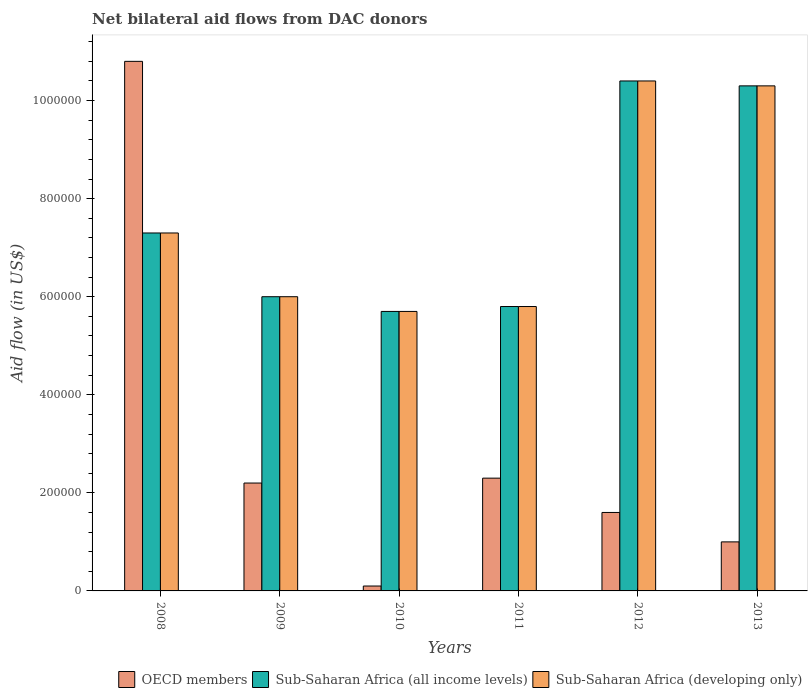How many different coloured bars are there?
Provide a succinct answer. 3. How many groups of bars are there?
Your response must be concise. 6. Are the number of bars per tick equal to the number of legend labels?
Your answer should be very brief. Yes. Are the number of bars on each tick of the X-axis equal?
Your answer should be compact. Yes. How many bars are there on the 5th tick from the left?
Your answer should be very brief. 3. In how many cases, is the number of bars for a given year not equal to the number of legend labels?
Your answer should be compact. 0. What is the net bilateral aid flow in Sub-Saharan Africa (all income levels) in 2008?
Give a very brief answer. 7.30e+05. Across all years, what is the maximum net bilateral aid flow in Sub-Saharan Africa (all income levels)?
Provide a succinct answer. 1.04e+06. Across all years, what is the minimum net bilateral aid flow in OECD members?
Your answer should be very brief. 10000. In which year was the net bilateral aid flow in Sub-Saharan Africa (developing only) minimum?
Keep it short and to the point. 2010. What is the total net bilateral aid flow in Sub-Saharan Africa (all income levels) in the graph?
Your answer should be very brief. 4.55e+06. What is the difference between the net bilateral aid flow in Sub-Saharan Africa (all income levels) in 2012 and that in 2013?
Your answer should be compact. 10000. What is the difference between the net bilateral aid flow in OECD members in 2009 and the net bilateral aid flow in Sub-Saharan Africa (developing only) in 2013?
Your answer should be compact. -8.10e+05. What is the average net bilateral aid flow in Sub-Saharan Africa (all income levels) per year?
Make the answer very short. 7.58e+05. In the year 2012, what is the difference between the net bilateral aid flow in OECD members and net bilateral aid flow in Sub-Saharan Africa (developing only)?
Give a very brief answer. -8.80e+05. In how many years, is the net bilateral aid flow in OECD members greater than 400000 US$?
Offer a terse response. 1. What is the ratio of the net bilateral aid flow in OECD members in 2009 to that in 2012?
Your response must be concise. 1.38. Is the net bilateral aid flow in OECD members in 2009 less than that in 2010?
Your answer should be compact. No. What is the difference between the highest and the second highest net bilateral aid flow in OECD members?
Your answer should be compact. 8.50e+05. What is the difference between the highest and the lowest net bilateral aid flow in OECD members?
Offer a very short reply. 1.07e+06. In how many years, is the net bilateral aid flow in Sub-Saharan Africa (all income levels) greater than the average net bilateral aid flow in Sub-Saharan Africa (all income levels) taken over all years?
Your answer should be compact. 2. What does the 2nd bar from the left in 2009 represents?
Make the answer very short. Sub-Saharan Africa (all income levels). What does the 1st bar from the right in 2010 represents?
Offer a terse response. Sub-Saharan Africa (developing only). How many bars are there?
Your answer should be very brief. 18. Are all the bars in the graph horizontal?
Keep it short and to the point. No. How many years are there in the graph?
Ensure brevity in your answer.  6. What is the difference between two consecutive major ticks on the Y-axis?
Offer a very short reply. 2.00e+05. Are the values on the major ticks of Y-axis written in scientific E-notation?
Ensure brevity in your answer.  No. Does the graph contain any zero values?
Your answer should be compact. No. Where does the legend appear in the graph?
Your answer should be very brief. Bottom right. How many legend labels are there?
Provide a short and direct response. 3. What is the title of the graph?
Your response must be concise. Net bilateral aid flows from DAC donors. Does "Belarus" appear as one of the legend labels in the graph?
Keep it short and to the point. No. What is the label or title of the Y-axis?
Your answer should be compact. Aid flow (in US$). What is the Aid flow (in US$) of OECD members in 2008?
Offer a terse response. 1.08e+06. What is the Aid flow (in US$) in Sub-Saharan Africa (all income levels) in 2008?
Offer a terse response. 7.30e+05. What is the Aid flow (in US$) in Sub-Saharan Africa (developing only) in 2008?
Your answer should be compact. 7.30e+05. What is the Aid flow (in US$) of Sub-Saharan Africa (all income levels) in 2009?
Offer a terse response. 6.00e+05. What is the Aid flow (in US$) in Sub-Saharan Africa (developing only) in 2009?
Offer a terse response. 6.00e+05. What is the Aid flow (in US$) of OECD members in 2010?
Your answer should be very brief. 10000. What is the Aid flow (in US$) of Sub-Saharan Africa (all income levels) in 2010?
Provide a succinct answer. 5.70e+05. What is the Aid flow (in US$) of Sub-Saharan Africa (developing only) in 2010?
Keep it short and to the point. 5.70e+05. What is the Aid flow (in US$) of OECD members in 2011?
Make the answer very short. 2.30e+05. What is the Aid flow (in US$) in Sub-Saharan Africa (all income levels) in 2011?
Give a very brief answer. 5.80e+05. What is the Aid flow (in US$) of Sub-Saharan Africa (developing only) in 2011?
Your answer should be compact. 5.80e+05. What is the Aid flow (in US$) in OECD members in 2012?
Your answer should be very brief. 1.60e+05. What is the Aid flow (in US$) in Sub-Saharan Africa (all income levels) in 2012?
Provide a short and direct response. 1.04e+06. What is the Aid flow (in US$) of Sub-Saharan Africa (developing only) in 2012?
Offer a terse response. 1.04e+06. What is the Aid flow (in US$) in Sub-Saharan Africa (all income levels) in 2013?
Your answer should be compact. 1.03e+06. What is the Aid flow (in US$) of Sub-Saharan Africa (developing only) in 2013?
Give a very brief answer. 1.03e+06. Across all years, what is the maximum Aid flow (in US$) in OECD members?
Provide a short and direct response. 1.08e+06. Across all years, what is the maximum Aid flow (in US$) of Sub-Saharan Africa (all income levels)?
Give a very brief answer. 1.04e+06. Across all years, what is the maximum Aid flow (in US$) of Sub-Saharan Africa (developing only)?
Provide a short and direct response. 1.04e+06. Across all years, what is the minimum Aid flow (in US$) in OECD members?
Keep it short and to the point. 10000. Across all years, what is the minimum Aid flow (in US$) in Sub-Saharan Africa (all income levels)?
Offer a very short reply. 5.70e+05. Across all years, what is the minimum Aid flow (in US$) in Sub-Saharan Africa (developing only)?
Provide a short and direct response. 5.70e+05. What is the total Aid flow (in US$) in OECD members in the graph?
Keep it short and to the point. 1.80e+06. What is the total Aid flow (in US$) in Sub-Saharan Africa (all income levels) in the graph?
Your answer should be compact. 4.55e+06. What is the total Aid flow (in US$) in Sub-Saharan Africa (developing only) in the graph?
Ensure brevity in your answer.  4.55e+06. What is the difference between the Aid flow (in US$) in OECD members in 2008 and that in 2009?
Your answer should be very brief. 8.60e+05. What is the difference between the Aid flow (in US$) of Sub-Saharan Africa (all income levels) in 2008 and that in 2009?
Ensure brevity in your answer.  1.30e+05. What is the difference between the Aid flow (in US$) of OECD members in 2008 and that in 2010?
Offer a very short reply. 1.07e+06. What is the difference between the Aid flow (in US$) in Sub-Saharan Africa (all income levels) in 2008 and that in 2010?
Ensure brevity in your answer.  1.60e+05. What is the difference between the Aid flow (in US$) in Sub-Saharan Africa (developing only) in 2008 and that in 2010?
Offer a very short reply. 1.60e+05. What is the difference between the Aid flow (in US$) of OECD members in 2008 and that in 2011?
Your answer should be very brief. 8.50e+05. What is the difference between the Aid flow (in US$) of Sub-Saharan Africa (all income levels) in 2008 and that in 2011?
Your response must be concise. 1.50e+05. What is the difference between the Aid flow (in US$) in Sub-Saharan Africa (developing only) in 2008 and that in 2011?
Offer a terse response. 1.50e+05. What is the difference between the Aid flow (in US$) of OECD members in 2008 and that in 2012?
Keep it short and to the point. 9.20e+05. What is the difference between the Aid flow (in US$) in Sub-Saharan Africa (all income levels) in 2008 and that in 2012?
Make the answer very short. -3.10e+05. What is the difference between the Aid flow (in US$) of Sub-Saharan Africa (developing only) in 2008 and that in 2012?
Provide a short and direct response. -3.10e+05. What is the difference between the Aid flow (in US$) in OECD members in 2008 and that in 2013?
Offer a terse response. 9.80e+05. What is the difference between the Aid flow (in US$) of OECD members in 2009 and that in 2010?
Your response must be concise. 2.10e+05. What is the difference between the Aid flow (in US$) of OECD members in 2009 and that in 2011?
Your answer should be compact. -10000. What is the difference between the Aid flow (in US$) of Sub-Saharan Africa (developing only) in 2009 and that in 2011?
Give a very brief answer. 2.00e+04. What is the difference between the Aid flow (in US$) in Sub-Saharan Africa (all income levels) in 2009 and that in 2012?
Offer a very short reply. -4.40e+05. What is the difference between the Aid flow (in US$) of Sub-Saharan Africa (developing only) in 2009 and that in 2012?
Your answer should be compact. -4.40e+05. What is the difference between the Aid flow (in US$) in OECD members in 2009 and that in 2013?
Give a very brief answer. 1.20e+05. What is the difference between the Aid flow (in US$) of Sub-Saharan Africa (all income levels) in 2009 and that in 2013?
Give a very brief answer. -4.30e+05. What is the difference between the Aid flow (in US$) of Sub-Saharan Africa (developing only) in 2009 and that in 2013?
Your answer should be very brief. -4.30e+05. What is the difference between the Aid flow (in US$) in OECD members in 2010 and that in 2011?
Provide a succinct answer. -2.20e+05. What is the difference between the Aid flow (in US$) in Sub-Saharan Africa (all income levels) in 2010 and that in 2012?
Your response must be concise. -4.70e+05. What is the difference between the Aid flow (in US$) of Sub-Saharan Africa (developing only) in 2010 and that in 2012?
Offer a terse response. -4.70e+05. What is the difference between the Aid flow (in US$) in Sub-Saharan Africa (all income levels) in 2010 and that in 2013?
Ensure brevity in your answer.  -4.60e+05. What is the difference between the Aid flow (in US$) in Sub-Saharan Africa (developing only) in 2010 and that in 2013?
Keep it short and to the point. -4.60e+05. What is the difference between the Aid flow (in US$) in Sub-Saharan Africa (all income levels) in 2011 and that in 2012?
Provide a short and direct response. -4.60e+05. What is the difference between the Aid flow (in US$) in Sub-Saharan Africa (developing only) in 2011 and that in 2012?
Offer a terse response. -4.60e+05. What is the difference between the Aid flow (in US$) of Sub-Saharan Africa (all income levels) in 2011 and that in 2013?
Make the answer very short. -4.50e+05. What is the difference between the Aid flow (in US$) of Sub-Saharan Africa (developing only) in 2011 and that in 2013?
Offer a terse response. -4.50e+05. What is the difference between the Aid flow (in US$) in Sub-Saharan Africa (all income levels) in 2012 and that in 2013?
Make the answer very short. 10000. What is the difference between the Aid flow (in US$) of Sub-Saharan Africa (developing only) in 2012 and that in 2013?
Ensure brevity in your answer.  10000. What is the difference between the Aid flow (in US$) in OECD members in 2008 and the Aid flow (in US$) in Sub-Saharan Africa (all income levels) in 2009?
Offer a very short reply. 4.80e+05. What is the difference between the Aid flow (in US$) of Sub-Saharan Africa (all income levels) in 2008 and the Aid flow (in US$) of Sub-Saharan Africa (developing only) in 2009?
Keep it short and to the point. 1.30e+05. What is the difference between the Aid flow (in US$) of OECD members in 2008 and the Aid flow (in US$) of Sub-Saharan Africa (all income levels) in 2010?
Your answer should be compact. 5.10e+05. What is the difference between the Aid flow (in US$) in OECD members in 2008 and the Aid flow (in US$) in Sub-Saharan Africa (developing only) in 2010?
Offer a very short reply. 5.10e+05. What is the difference between the Aid flow (in US$) of Sub-Saharan Africa (all income levels) in 2008 and the Aid flow (in US$) of Sub-Saharan Africa (developing only) in 2010?
Give a very brief answer. 1.60e+05. What is the difference between the Aid flow (in US$) in OECD members in 2008 and the Aid flow (in US$) in Sub-Saharan Africa (developing only) in 2011?
Keep it short and to the point. 5.00e+05. What is the difference between the Aid flow (in US$) of Sub-Saharan Africa (all income levels) in 2008 and the Aid flow (in US$) of Sub-Saharan Africa (developing only) in 2011?
Provide a succinct answer. 1.50e+05. What is the difference between the Aid flow (in US$) of OECD members in 2008 and the Aid flow (in US$) of Sub-Saharan Africa (developing only) in 2012?
Offer a very short reply. 4.00e+04. What is the difference between the Aid flow (in US$) in Sub-Saharan Africa (all income levels) in 2008 and the Aid flow (in US$) in Sub-Saharan Africa (developing only) in 2012?
Your answer should be compact. -3.10e+05. What is the difference between the Aid flow (in US$) of Sub-Saharan Africa (all income levels) in 2008 and the Aid flow (in US$) of Sub-Saharan Africa (developing only) in 2013?
Ensure brevity in your answer.  -3.00e+05. What is the difference between the Aid flow (in US$) of OECD members in 2009 and the Aid flow (in US$) of Sub-Saharan Africa (all income levels) in 2010?
Make the answer very short. -3.50e+05. What is the difference between the Aid flow (in US$) of OECD members in 2009 and the Aid flow (in US$) of Sub-Saharan Africa (developing only) in 2010?
Your response must be concise. -3.50e+05. What is the difference between the Aid flow (in US$) of OECD members in 2009 and the Aid flow (in US$) of Sub-Saharan Africa (all income levels) in 2011?
Your answer should be compact. -3.60e+05. What is the difference between the Aid flow (in US$) in OECD members in 2009 and the Aid flow (in US$) in Sub-Saharan Africa (developing only) in 2011?
Offer a terse response. -3.60e+05. What is the difference between the Aid flow (in US$) in Sub-Saharan Africa (all income levels) in 2009 and the Aid flow (in US$) in Sub-Saharan Africa (developing only) in 2011?
Ensure brevity in your answer.  2.00e+04. What is the difference between the Aid flow (in US$) of OECD members in 2009 and the Aid flow (in US$) of Sub-Saharan Africa (all income levels) in 2012?
Your response must be concise. -8.20e+05. What is the difference between the Aid flow (in US$) in OECD members in 2009 and the Aid flow (in US$) in Sub-Saharan Africa (developing only) in 2012?
Provide a succinct answer. -8.20e+05. What is the difference between the Aid flow (in US$) in Sub-Saharan Africa (all income levels) in 2009 and the Aid flow (in US$) in Sub-Saharan Africa (developing only) in 2012?
Offer a terse response. -4.40e+05. What is the difference between the Aid flow (in US$) of OECD members in 2009 and the Aid flow (in US$) of Sub-Saharan Africa (all income levels) in 2013?
Provide a short and direct response. -8.10e+05. What is the difference between the Aid flow (in US$) of OECD members in 2009 and the Aid flow (in US$) of Sub-Saharan Africa (developing only) in 2013?
Your response must be concise. -8.10e+05. What is the difference between the Aid flow (in US$) in Sub-Saharan Africa (all income levels) in 2009 and the Aid flow (in US$) in Sub-Saharan Africa (developing only) in 2013?
Ensure brevity in your answer.  -4.30e+05. What is the difference between the Aid flow (in US$) in OECD members in 2010 and the Aid flow (in US$) in Sub-Saharan Africa (all income levels) in 2011?
Give a very brief answer. -5.70e+05. What is the difference between the Aid flow (in US$) in OECD members in 2010 and the Aid flow (in US$) in Sub-Saharan Africa (developing only) in 2011?
Offer a very short reply. -5.70e+05. What is the difference between the Aid flow (in US$) in Sub-Saharan Africa (all income levels) in 2010 and the Aid flow (in US$) in Sub-Saharan Africa (developing only) in 2011?
Offer a terse response. -10000. What is the difference between the Aid flow (in US$) in OECD members in 2010 and the Aid flow (in US$) in Sub-Saharan Africa (all income levels) in 2012?
Ensure brevity in your answer.  -1.03e+06. What is the difference between the Aid flow (in US$) of OECD members in 2010 and the Aid flow (in US$) of Sub-Saharan Africa (developing only) in 2012?
Offer a terse response. -1.03e+06. What is the difference between the Aid flow (in US$) of Sub-Saharan Africa (all income levels) in 2010 and the Aid flow (in US$) of Sub-Saharan Africa (developing only) in 2012?
Give a very brief answer. -4.70e+05. What is the difference between the Aid flow (in US$) in OECD members in 2010 and the Aid flow (in US$) in Sub-Saharan Africa (all income levels) in 2013?
Your response must be concise. -1.02e+06. What is the difference between the Aid flow (in US$) in OECD members in 2010 and the Aid flow (in US$) in Sub-Saharan Africa (developing only) in 2013?
Give a very brief answer. -1.02e+06. What is the difference between the Aid flow (in US$) of Sub-Saharan Africa (all income levels) in 2010 and the Aid flow (in US$) of Sub-Saharan Africa (developing only) in 2013?
Offer a terse response. -4.60e+05. What is the difference between the Aid flow (in US$) of OECD members in 2011 and the Aid flow (in US$) of Sub-Saharan Africa (all income levels) in 2012?
Give a very brief answer. -8.10e+05. What is the difference between the Aid flow (in US$) in OECD members in 2011 and the Aid flow (in US$) in Sub-Saharan Africa (developing only) in 2012?
Ensure brevity in your answer.  -8.10e+05. What is the difference between the Aid flow (in US$) of Sub-Saharan Africa (all income levels) in 2011 and the Aid flow (in US$) of Sub-Saharan Africa (developing only) in 2012?
Your answer should be compact. -4.60e+05. What is the difference between the Aid flow (in US$) of OECD members in 2011 and the Aid flow (in US$) of Sub-Saharan Africa (all income levels) in 2013?
Offer a terse response. -8.00e+05. What is the difference between the Aid flow (in US$) of OECD members in 2011 and the Aid flow (in US$) of Sub-Saharan Africa (developing only) in 2013?
Ensure brevity in your answer.  -8.00e+05. What is the difference between the Aid flow (in US$) of Sub-Saharan Africa (all income levels) in 2011 and the Aid flow (in US$) of Sub-Saharan Africa (developing only) in 2013?
Your answer should be very brief. -4.50e+05. What is the difference between the Aid flow (in US$) of OECD members in 2012 and the Aid flow (in US$) of Sub-Saharan Africa (all income levels) in 2013?
Your answer should be compact. -8.70e+05. What is the difference between the Aid flow (in US$) in OECD members in 2012 and the Aid flow (in US$) in Sub-Saharan Africa (developing only) in 2013?
Provide a short and direct response. -8.70e+05. What is the average Aid flow (in US$) of Sub-Saharan Africa (all income levels) per year?
Provide a short and direct response. 7.58e+05. What is the average Aid flow (in US$) of Sub-Saharan Africa (developing only) per year?
Provide a succinct answer. 7.58e+05. In the year 2008, what is the difference between the Aid flow (in US$) in OECD members and Aid flow (in US$) in Sub-Saharan Africa (all income levels)?
Your answer should be very brief. 3.50e+05. In the year 2008, what is the difference between the Aid flow (in US$) in OECD members and Aid flow (in US$) in Sub-Saharan Africa (developing only)?
Offer a terse response. 3.50e+05. In the year 2009, what is the difference between the Aid flow (in US$) in OECD members and Aid flow (in US$) in Sub-Saharan Africa (all income levels)?
Keep it short and to the point. -3.80e+05. In the year 2009, what is the difference between the Aid flow (in US$) of OECD members and Aid flow (in US$) of Sub-Saharan Africa (developing only)?
Ensure brevity in your answer.  -3.80e+05. In the year 2010, what is the difference between the Aid flow (in US$) in OECD members and Aid flow (in US$) in Sub-Saharan Africa (all income levels)?
Your answer should be compact. -5.60e+05. In the year 2010, what is the difference between the Aid flow (in US$) in OECD members and Aid flow (in US$) in Sub-Saharan Africa (developing only)?
Give a very brief answer. -5.60e+05. In the year 2011, what is the difference between the Aid flow (in US$) of OECD members and Aid flow (in US$) of Sub-Saharan Africa (all income levels)?
Offer a terse response. -3.50e+05. In the year 2011, what is the difference between the Aid flow (in US$) of OECD members and Aid flow (in US$) of Sub-Saharan Africa (developing only)?
Give a very brief answer. -3.50e+05. In the year 2012, what is the difference between the Aid flow (in US$) of OECD members and Aid flow (in US$) of Sub-Saharan Africa (all income levels)?
Offer a terse response. -8.80e+05. In the year 2012, what is the difference between the Aid flow (in US$) in OECD members and Aid flow (in US$) in Sub-Saharan Africa (developing only)?
Your response must be concise. -8.80e+05. In the year 2012, what is the difference between the Aid flow (in US$) of Sub-Saharan Africa (all income levels) and Aid flow (in US$) of Sub-Saharan Africa (developing only)?
Make the answer very short. 0. In the year 2013, what is the difference between the Aid flow (in US$) in OECD members and Aid flow (in US$) in Sub-Saharan Africa (all income levels)?
Your response must be concise. -9.30e+05. In the year 2013, what is the difference between the Aid flow (in US$) of OECD members and Aid flow (in US$) of Sub-Saharan Africa (developing only)?
Your answer should be compact. -9.30e+05. In the year 2013, what is the difference between the Aid flow (in US$) in Sub-Saharan Africa (all income levels) and Aid flow (in US$) in Sub-Saharan Africa (developing only)?
Make the answer very short. 0. What is the ratio of the Aid flow (in US$) in OECD members in 2008 to that in 2009?
Provide a short and direct response. 4.91. What is the ratio of the Aid flow (in US$) in Sub-Saharan Africa (all income levels) in 2008 to that in 2009?
Ensure brevity in your answer.  1.22. What is the ratio of the Aid flow (in US$) of Sub-Saharan Africa (developing only) in 2008 to that in 2009?
Your answer should be compact. 1.22. What is the ratio of the Aid flow (in US$) of OECD members in 2008 to that in 2010?
Ensure brevity in your answer.  108. What is the ratio of the Aid flow (in US$) of Sub-Saharan Africa (all income levels) in 2008 to that in 2010?
Ensure brevity in your answer.  1.28. What is the ratio of the Aid flow (in US$) in Sub-Saharan Africa (developing only) in 2008 to that in 2010?
Your answer should be very brief. 1.28. What is the ratio of the Aid flow (in US$) of OECD members in 2008 to that in 2011?
Make the answer very short. 4.7. What is the ratio of the Aid flow (in US$) of Sub-Saharan Africa (all income levels) in 2008 to that in 2011?
Your answer should be compact. 1.26. What is the ratio of the Aid flow (in US$) of Sub-Saharan Africa (developing only) in 2008 to that in 2011?
Ensure brevity in your answer.  1.26. What is the ratio of the Aid flow (in US$) in OECD members in 2008 to that in 2012?
Your answer should be compact. 6.75. What is the ratio of the Aid flow (in US$) in Sub-Saharan Africa (all income levels) in 2008 to that in 2012?
Offer a very short reply. 0.7. What is the ratio of the Aid flow (in US$) of Sub-Saharan Africa (developing only) in 2008 to that in 2012?
Give a very brief answer. 0.7. What is the ratio of the Aid flow (in US$) in Sub-Saharan Africa (all income levels) in 2008 to that in 2013?
Your answer should be very brief. 0.71. What is the ratio of the Aid flow (in US$) of Sub-Saharan Africa (developing only) in 2008 to that in 2013?
Offer a very short reply. 0.71. What is the ratio of the Aid flow (in US$) of OECD members in 2009 to that in 2010?
Your response must be concise. 22. What is the ratio of the Aid flow (in US$) of Sub-Saharan Africa (all income levels) in 2009 to that in 2010?
Your response must be concise. 1.05. What is the ratio of the Aid flow (in US$) in Sub-Saharan Africa (developing only) in 2009 to that in 2010?
Your answer should be very brief. 1.05. What is the ratio of the Aid flow (in US$) in OECD members in 2009 to that in 2011?
Offer a very short reply. 0.96. What is the ratio of the Aid flow (in US$) of Sub-Saharan Africa (all income levels) in 2009 to that in 2011?
Provide a succinct answer. 1.03. What is the ratio of the Aid flow (in US$) in Sub-Saharan Africa (developing only) in 2009 to that in 2011?
Provide a succinct answer. 1.03. What is the ratio of the Aid flow (in US$) of OECD members in 2009 to that in 2012?
Give a very brief answer. 1.38. What is the ratio of the Aid flow (in US$) of Sub-Saharan Africa (all income levels) in 2009 to that in 2012?
Provide a succinct answer. 0.58. What is the ratio of the Aid flow (in US$) of Sub-Saharan Africa (developing only) in 2009 to that in 2012?
Your answer should be very brief. 0.58. What is the ratio of the Aid flow (in US$) of Sub-Saharan Africa (all income levels) in 2009 to that in 2013?
Give a very brief answer. 0.58. What is the ratio of the Aid flow (in US$) of Sub-Saharan Africa (developing only) in 2009 to that in 2013?
Offer a very short reply. 0.58. What is the ratio of the Aid flow (in US$) in OECD members in 2010 to that in 2011?
Give a very brief answer. 0.04. What is the ratio of the Aid flow (in US$) of Sub-Saharan Africa (all income levels) in 2010 to that in 2011?
Provide a short and direct response. 0.98. What is the ratio of the Aid flow (in US$) of Sub-Saharan Africa (developing only) in 2010 to that in 2011?
Your response must be concise. 0.98. What is the ratio of the Aid flow (in US$) in OECD members in 2010 to that in 2012?
Offer a terse response. 0.06. What is the ratio of the Aid flow (in US$) in Sub-Saharan Africa (all income levels) in 2010 to that in 2012?
Your answer should be compact. 0.55. What is the ratio of the Aid flow (in US$) of Sub-Saharan Africa (developing only) in 2010 to that in 2012?
Provide a short and direct response. 0.55. What is the ratio of the Aid flow (in US$) of OECD members in 2010 to that in 2013?
Your response must be concise. 0.1. What is the ratio of the Aid flow (in US$) in Sub-Saharan Africa (all income levels) in 2010 to that in 2013?
Keep it short and to the point. 0.55. What is the ratio of the Aid flow (in US$) of Sub-Saharan Africa (developing only) in 2010 to that in 2013?
Your answer should be compact. 0.55. What is the ratio of the Aid flow (in US$) of OECD members in 2011 to that in 2012?
Give a very brief answer. 1.44. What is the ratio of the Aid flow (in US$) in Sub-Saharan Africa (all income levels) in 2011 to that in 2012?
Make the answer very short. 0.56. What is the ratio of the Aid flow (in US$) of Sub-Saharan Africa (developing only) in 2011 to that in 2012?
Make the answer very short. 0.56. What is the ratio of the Aid flow (in US$) of OECD members in 2011 to that in 2013?
Offer a very short reply. 2.3. What is the ratio of the Aid flow (in US$) in Sub-Saharan Africa (all income levels) in 2011 to that in 2013?
Provide a succinct answer. 0.56. What is the ratio of the Aid flow (in US$) of Sub-Saharan Africa (developing only) in 2011 to that in 2013?
Provide a short and direct response. 0.56. What is the ratio of the Aid flow (in US$) of Sub-Saharan Africa (all income levels) in 2012 to that in 2013?
Your answer should be very brief. 1.01. What is the ratio of the Aid flow (in US$) in Sub-Saharan Africa (developing only) in 2012 to that in 2013?
Provide a short and direct response. 1.01. What is the difference between the highest and the second highest Aid flow (in US$) in OECD members?
Keep it short and to the point. 8.50e+05. What is the difference between the highest and the second highest Aid flow (in US$) of Sub-Saharan Africa (developing only)?
Offer a very short reply. 10000. What is the difference between the highest and the lowest Aid flow (in US$) in OECD members?
Make the answer very short. 1.07e+06. What is the difference between the highest and the lowest Aid flow (in US$) of Sub-Saharan Africa (all income levels)?
Give a very brief answer. 4.70e+05. 